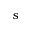<formula> <loc_0><loc_0><loc_500><loc_500>s</formula> 